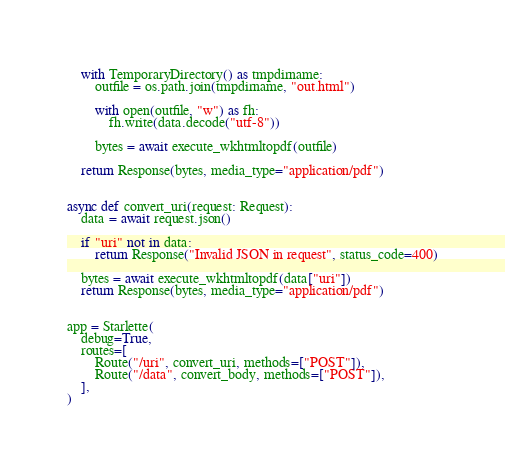<code> <loc_0><loc_0><loc_500><loc_500><_Python_>
    with TemporaryDirectory() as tmpdirname:
        outfile = os.path.join(tmpdirname, "out.html")

        with open(outfile, "w") as fh:
            fh.write(data.decode("utf-8"))

        bytes = await execute_wkhtmltopdf(outfile)

    return Response(bytes, media_type="application/pdf")


async def convert_uri(request: Request):
    data = await request.json()

    if "uri" not in data:
        return Response("Invalid JSON in request", status_code=400)

    bytes = await execute_wkhtmltopdf(data["uri"])
    return Response(bytes, media_type="application/pdf")


app = Starlette(
    debug=True,
    routes=[
        Route("/uri", convert_uri, methods=["POST"]),
        Route("/data", convert_body, methods=["POST"]),
    ],
)
</code> 